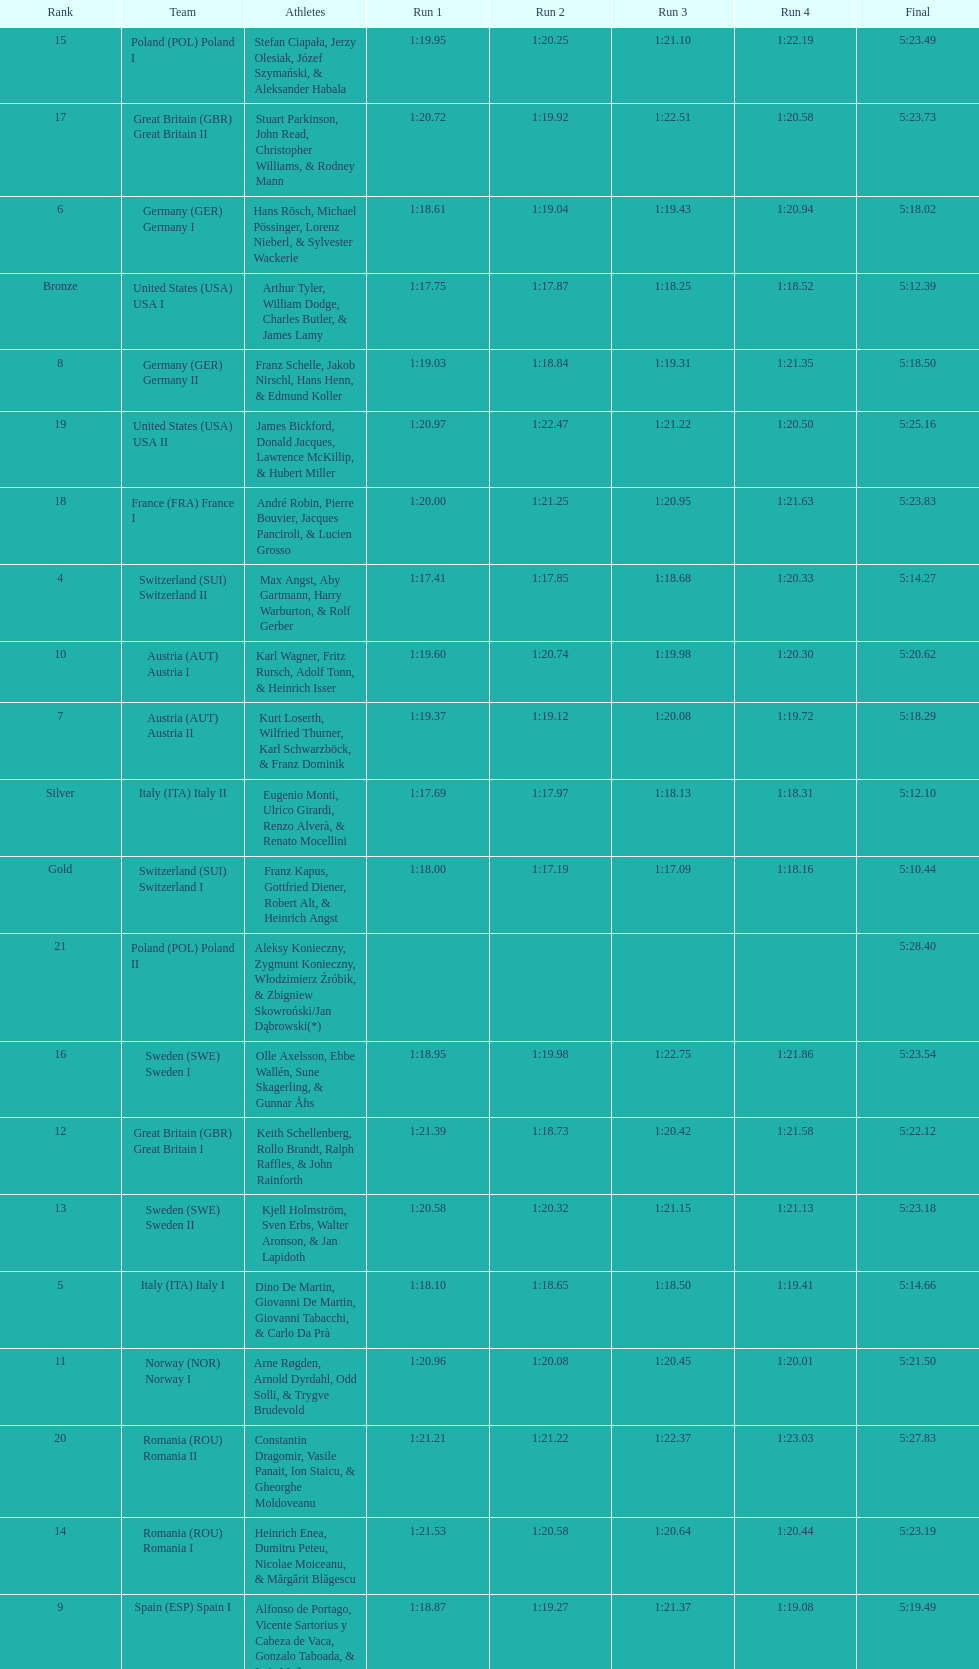What is the total amount of runs? 4. 